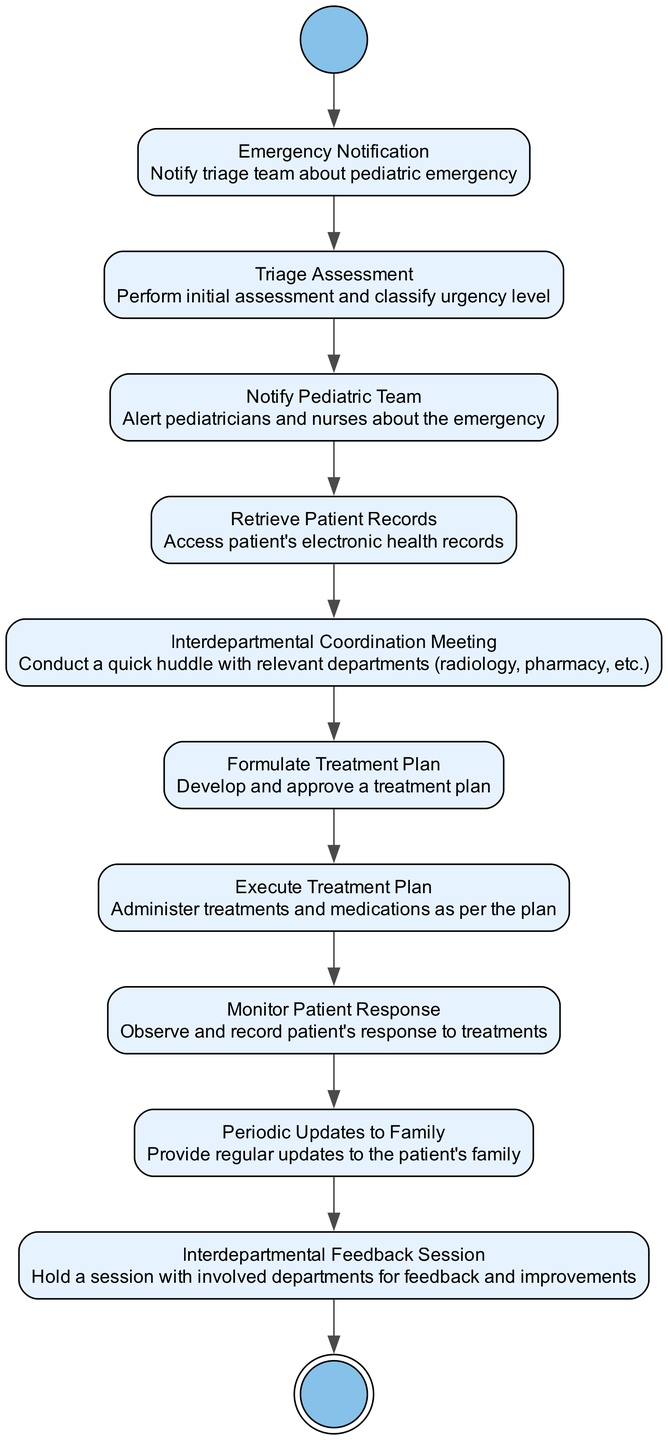What is the first action in the diagram? The diagram starts with the "Emergency Notification" action, which is the first step after the initial node indicating the beginning of the process.
Answer: Emergency Notification How many actions are there in total? By counting the actions listed in the diagram, there are 10 distinct actions present that describe the steps taken during the pediatric emergency management process.
Answer: 10 What happens after "Triage Assessment"? Following "Triage Assessment," the next action in the sequence is "Notify Pediatric Team," which indicates that after assessing the urgency, the pediatricians and nurses are alerted.
Answer: Notify Pediatric Team Which action directly precedes "Formulate Treatment Plan"? The action immediately before "Formulate Treatment Plan" is "Interdepartmental Coordination Meeting," indicating that a coordination meeting must occur before formulating the treatment plan.
Answer: Interdepartmental Coordination Meeting What is the last step of the process? The final step in the diagram is represented by the "End" node, signifying the completion of the pediatric emergency management process after all actions have been performed.
Answer: End What is the purpose of the "Interdepartmental Feedback Session"? This session is aimed at discussing feedback and improvements involving the departments that participated in managing the pediatric emergency, allowing for reflective practices to enhance future responses.
Answer: Feedback and improvements How many edges connect the nodes in the diagram? Since each action is connected in a sequential flow from the start to the end, there are 11 edges connecting these nodes, including the initial node.
Answer: 11 What action follows "Execute Treatment Plan"? After "Execute Treatment Plan," the subsequent action is "Monitor Patient Response," which indicates the need to observe and assess the patient's reaction to the implemented treatments.
Answer: Monitor Patient Response 